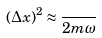<formula> <loc_0><loc_0><loc_500><loc_500>( \Delta x ) ^ { 2 } \approx \frac { } { 2 m \omega }</formula> 